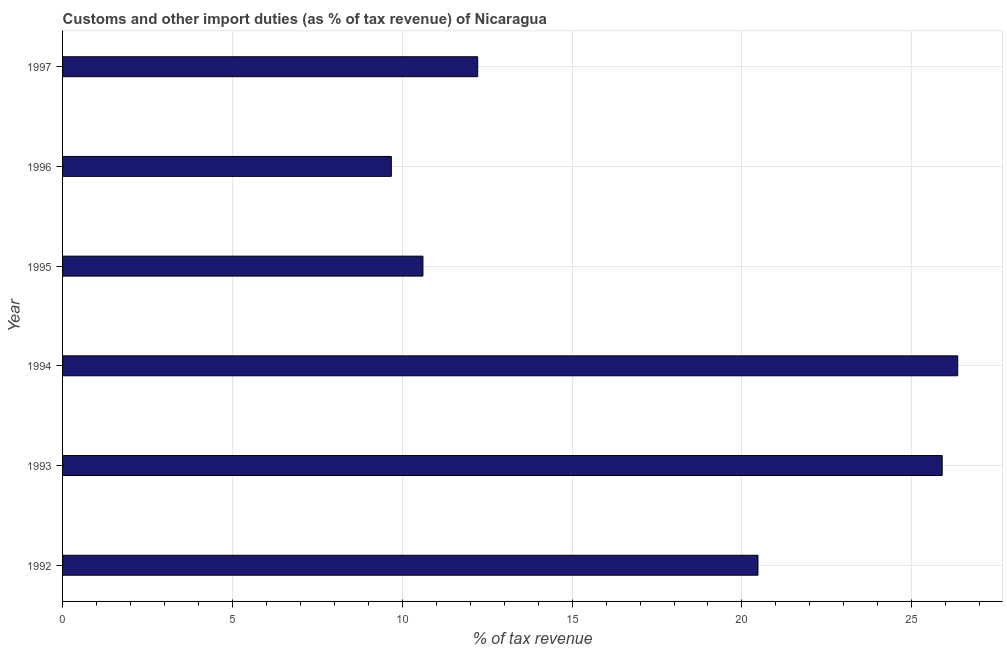Does the graph contain grids?
Your response must be concise. Yes. What is the title of the graph?
Provide a short and direct response. Customs and other import duties (as % of tax revenue) of Nicaragua. What is the label or title of the X-axis?
Keep it short and to the point. % of tax revenue. What is the customs and other import duties in 1994?
Offer a terse response. 26.35. Across all years, what is the maximum customs and other import duties?
Provide a short and direct response. 26.35. Across all years, what is the minimum customs and other import duties?
Keep it short and to the point. 9.68. What is the sum of the customs and other import duties?
Ensure brevity in your answer.  105.23. What is the difference between the customs and other import duties in 1992 and 1994?
Your answer should be compact. -5.88. What is the average customs and other import duties per year?
Offer a terse response. 17.54. What is the median customs and other import duties?
Offer a very short reply. 16.35. What is the ratio of the customs and other import duties in 1992 to that in 1994?
Offer a very short reply. 0.78. Is the difference between the customs and other import duties in 1993 and 1996 greater than the difference between any two years?
Ensure brevity in your answer.  No. What is the difference between the highest and the second highest customs and other import duties?
Your answer should be compact. 0.46. What is the difference between the highest and the lowest customs and other import duties?
Ensure brevity in your answer.  16.67. How many bars are there?
Your response must be concise. 6. How many years are there in the graph?
Ensure brevity in your answer.  6. What is the difference between two consecutive major ticks on the X-axis?
Keep it short and to the point. 5. What is the % of tax revenue in 1992?
Keep it short and to the point. 20.47. What is the % of tax revenue in 1993?
Your answer should be very brief. 25.89. What is the % of tax revenue in 1994?
Your response must be concise. 26.35. What is the % of tax revenue in 1995?
Your answer should be very brief. 10.61. What is the % of tax revenue of 1996?
Your answer should be compact. 9.68. What is the % of tax revenue in 1997?
Ensure brevity in your answer.  12.22. What is the difference between the % of tax revenue in 1992 and 1993?
Offer a very short reply. -5.42. What is the difference between the % of tax revenue in 1992 and 1994?
Ensure brevity in your answer.  -5.88. What is the difference between the % of tax revenue in 1992 and 1995?
Offer a terse response. 9.86. What is the difference between the % of tax revenue in 1992 and 1996?
Keep it short and to the point. 10.79. What is the difference between the % of tax revenue in 1992 and 1997?
Provide a short and direct response. 8.25. What is the difference between the % of tax revenue in 1993 and 1994?
Your response must be concise. -0.46. What is the difference between the % of tax revenue in 1993 and 1995?
Provide a short and direct response. 15.29. What is the difference between the % of tax revenue in 1993 and 1996?
Offer a terse response. 16.22. What is the difference between the % of tax revenue in 1993 and 1997?
Keep it short and to the point. 13.67. What is the difference between the % of tax revenue in 1994 and 1995?
Your answer should be very brief. 15.74. What is the difference between the % of tax revenue in 1994 and 1996?
Ensure brevity in your answer.  16.67. What is the difference between the % of tax revenue in 1994 and 1997?
Keep it short and to the point. 14.13. What is the difference between the % of tax revenue in 1995 and 1996?
Your answer should be very brief. 0.93. What is the difference between the % of tax revenue in 1995 and 1997?
Offer a very short reply. -1.61. What is the difference between the % of tax revenue in 1996 and 1997?
Offer a very short reply. -2.54. What is the ratio of the % of tax revenue in 1992 to that in 1993?
Make the answer very short. 0.79. What is the ratio of the % of tax revenue in 1992 to that in 1994?
Offer a very short reply. 0.78. What is the ratio of the % of tax revenue in 1992 to that in 1995?
Provide a short and direct response. 1.93. What is the ratio of the % of tax revenue in 1992 to that in 1996?
Your response must be concise. 2.12. What is the ratio of the % of tax revenue in 1992 to that in 1997?
Offer a terse response. 1.68. What is the ratio of the % of tax revenue in 1993 to that in 1995?
Offer a terse response. 2.44. What is the ratio of the % of tax revenue in 1993 to that in 1996?
Provide a succinct answer. 2.68. What is the ratio of the % of tax revenue in 1993 to that in 1997?
Your response must be concise. 2.12. What is the ratio of the % of tax revenue in 1994 to that in 1995?
Your response must be concise. 2.48. What is the ratio of the % of tax revenue in 1994 to that in 1996?
Make the answer very short. 2.72. What is the ratio of the % of tax revenue in 1994 to that in 1997?
Make the answer very short. 2.16. What is the ratio of the % of tax revenue in 1995 to that in 1996?
Provide a succinct answer. 1.1. What is the ratio of the % of tax revenue in 1995 to that in 1997?
Your answer should be very brief. 0.87. What is the ratio of the % of tax revenue in 1996 to that in 1997?
Offer a very short reply. 0.79. 